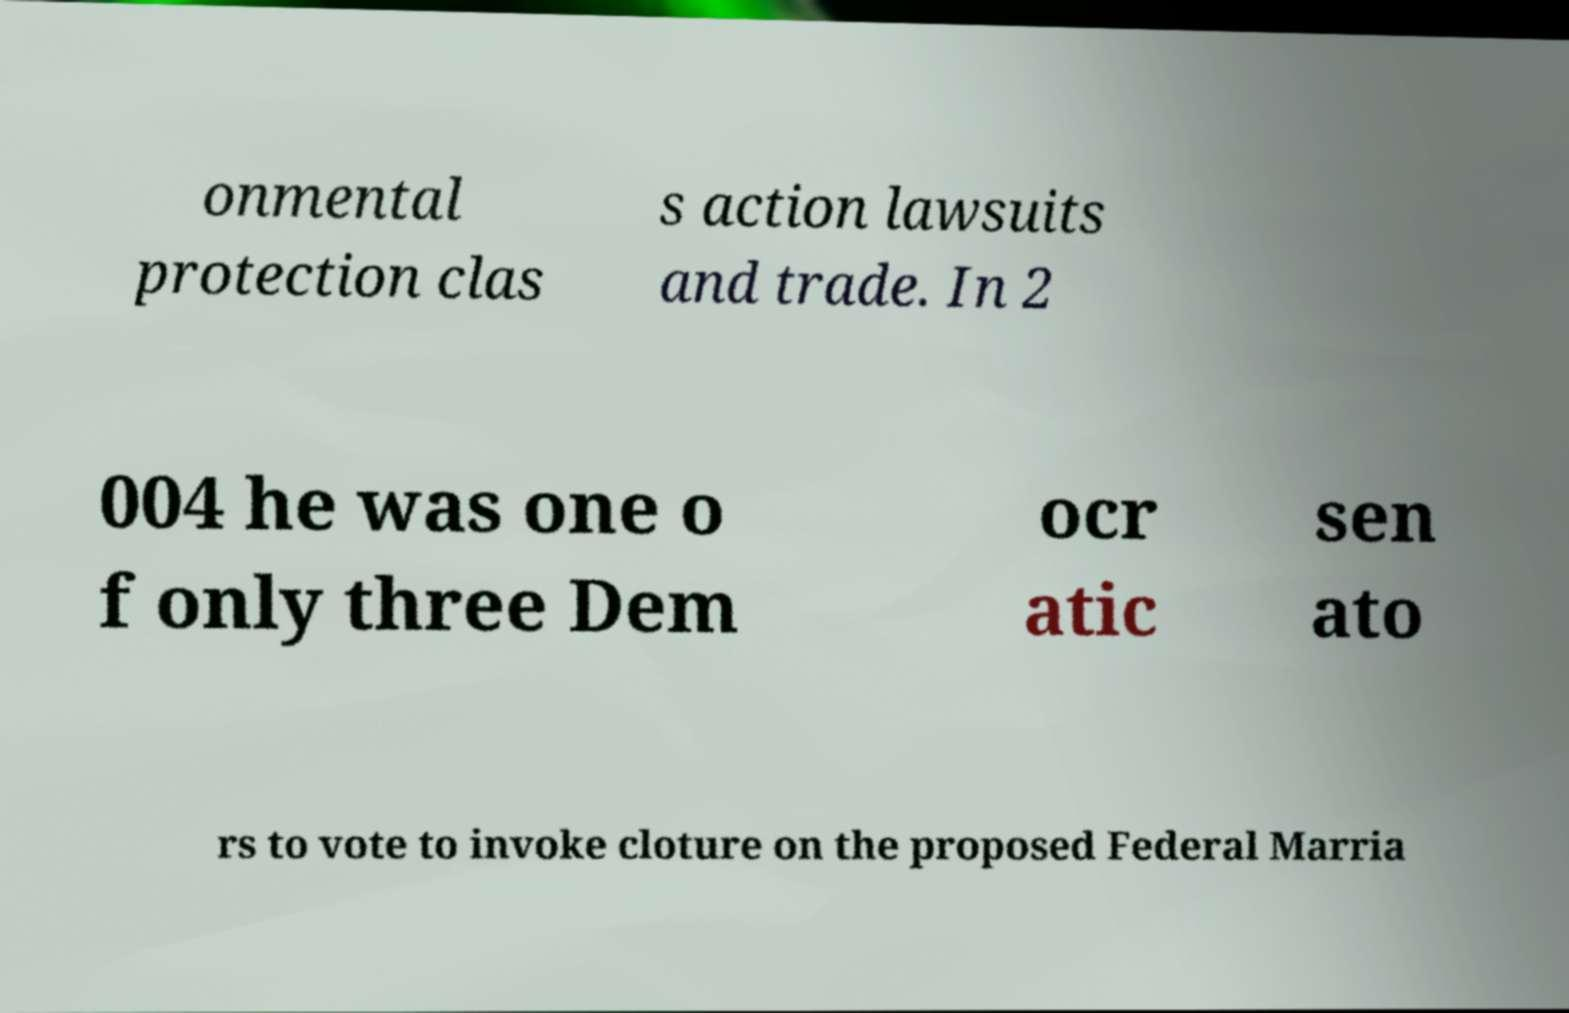I need the written content from this picture converted into text. Can you do that? onmental protection clas s action lawsuits and trade. In 2 004 he was one o f only three Dem ocr atic sen ato rs to vote to invoke cloture on the proposed Federal Marria 